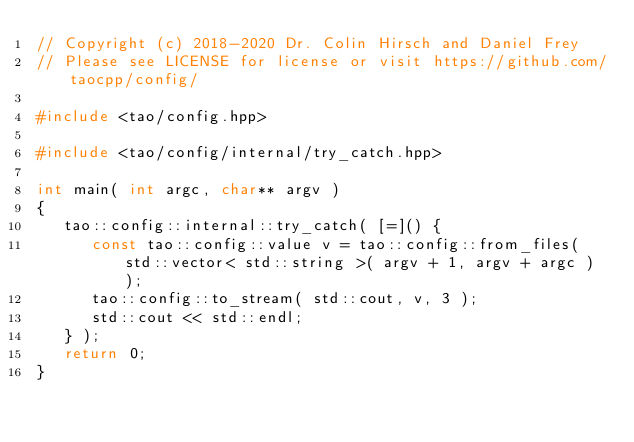<code> <loc_0><loc_0><loc_500><loc_500><_C++_>// Copyright (c) 2018-2020 Dr. Colin Hirsch and Daniel Frey
// Please see LICENSE for license or visit https://github.com/taocpp/config/

#include <tao/config.hpp>

#include <tao/config/internal/try_catch.hpp>

int main( int argc, char** argv )
{
   tao::config::internal::try_catch( [=]() {
      const tao::config::value v = tao::config::from_files( std::vector< std::string >( argv + 1, argv + argc ) );
      tao::config::to_stream( std::cout, v, 3 );
      std::cout << std::endl;
   } );
   return 0;
}
</code> 